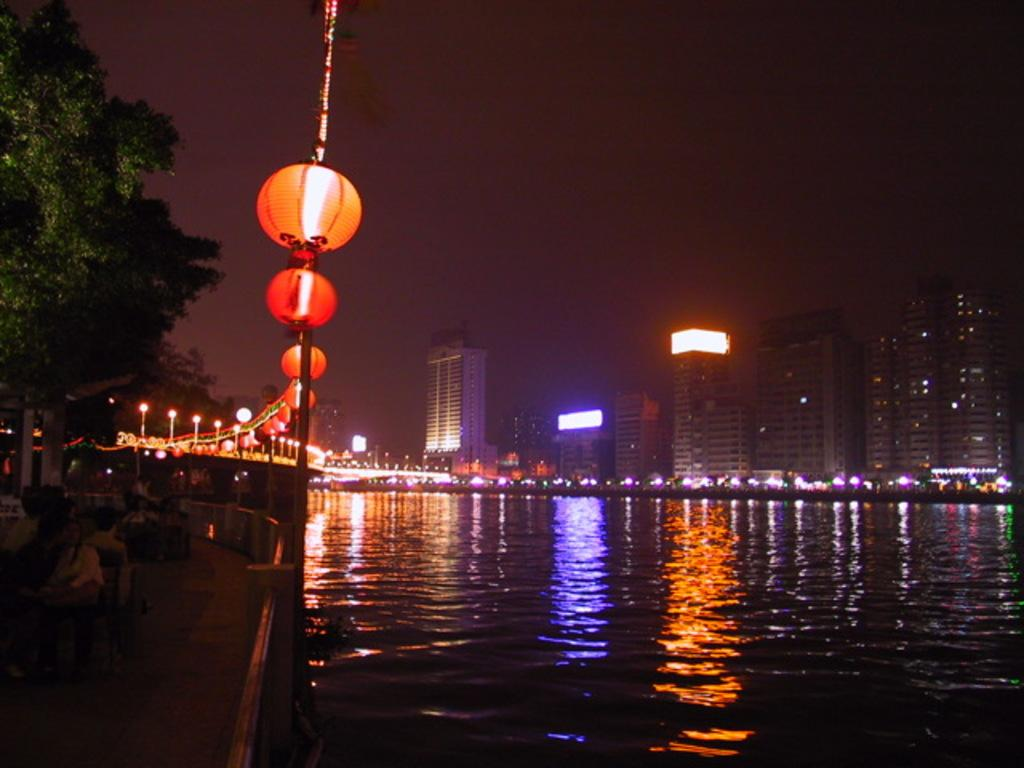What can be seen in the center of the image? The sky is visible in the center of the image. What type of structures are present in the image? There are buildings in the image. What might be used for illumination in the image? Lights and lanterns are present in the image. What natural elements can be seen in the image? There is water and trees visible in the image. Are there any people in the image? Yes, there are people in the image. Can you describe any other objects present in the image? There are other unspecified objects in the image. How does the coat feel in the image? There is no coat present in the image, so it is not possible to determine how it might feel. 